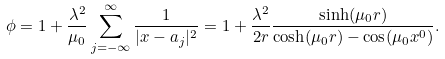Convert formula to latex. <formula><loc_0><loc_0><loc_500><loc_500>\phi = 1 + \frac { \lambda ^ { 2 } } { \mu _ { 0 } } \sum _ { j = - \infty } ^ { \infty } \frac { 1 } { | x - a _ { j } | ^ { 2 } } = 1 + \frac { \lambda ^ { 2 } } { 2 r } \frac { \sinh ( \mu _ { 0 } r ) } { \cosh ( \mu _ { 0 } r ) - \cos ( \mu _ { 0 } x ^ { 0 } ) } .</formula> 